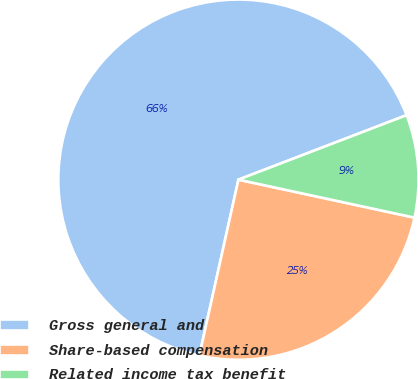<chart> <loc_0><loc_0><loc_500><loc_500><pie_chart><fcel>Gross general and<fcel>Share-based compensation<fcel>Related income tax benefit<nl><fcel>65.69%<fcel>25.1%<fcel>9.21%<nl></chart> 